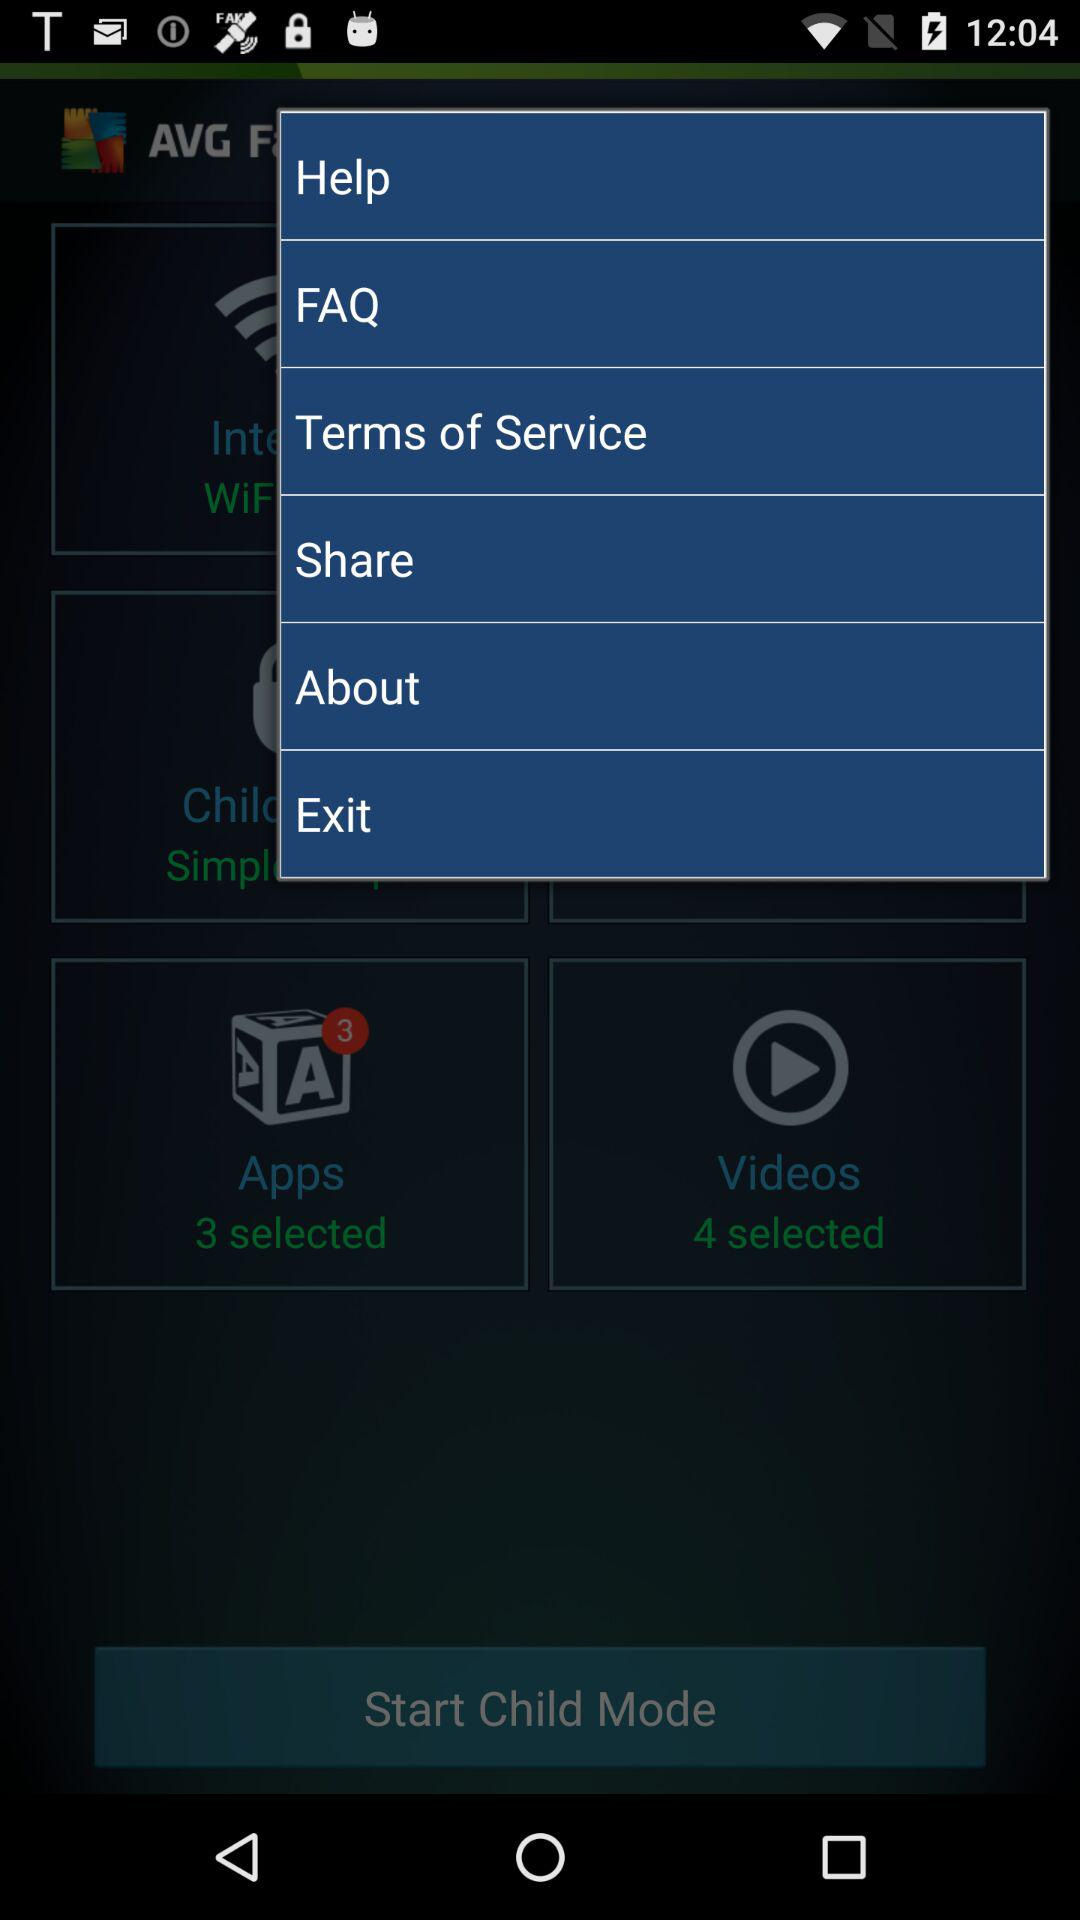What is the number of the selected videos? There are four selected videos. 